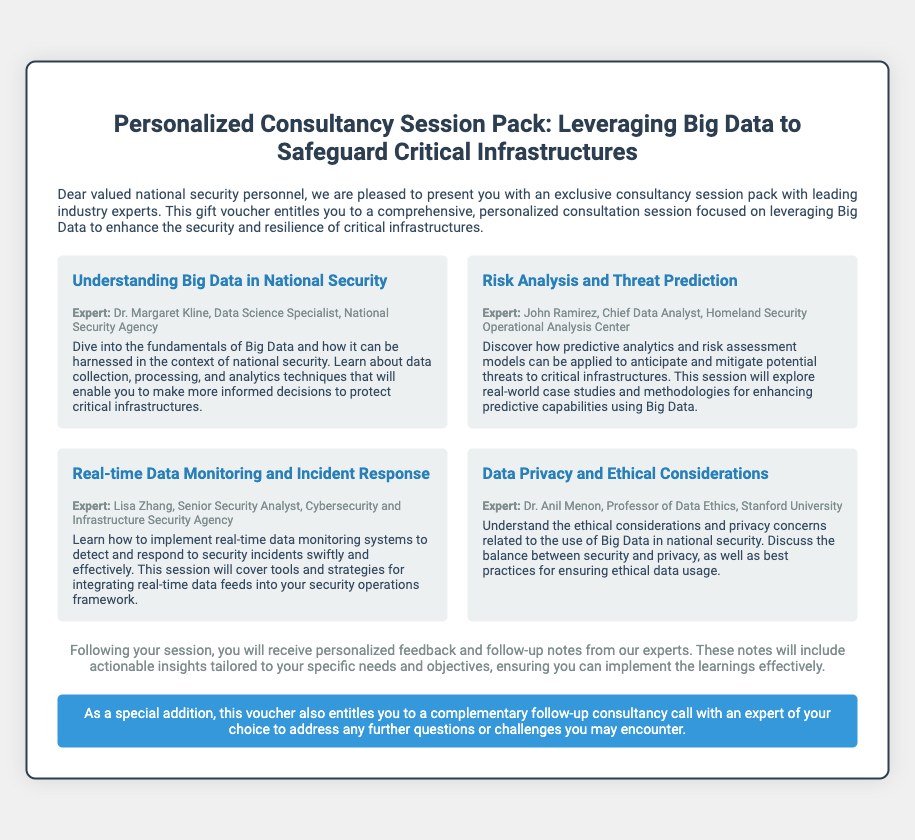What is the title of the consultancy session pack? The title of the pack is prominently displayed at the top of the document.
Answer: Personalized Consultancy Session Pack: Leveraging Big Data to Safeguard Critical Infrastructures Who is the expert for the session on "Data Privacy and Ethical Considerations"? The name of the expert is mentioned in conjunction with the session title.
Answer: Dr. Anil Menon What is included with the consultancy sessions? The document states what participants will receive after the sessions.
Answer: Personalized feedback and follow-up notes How many sessions are listed in the voucher? By counting the distinct sessions described in the document, we can determine the number.
Answer: Four What is the special addition offered with the voucher? The document mentions an added benefit unique to the voucher offer.
Answer: A complementary follow-up consultancy call Who is the expert for "Real-time Data Monitoring and Incident Response"? The expert is referenced in the context of this specific session.
Answer: Lisa Zhang 